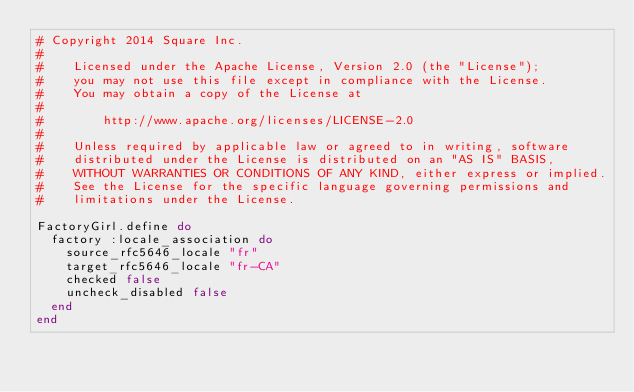<code> <loc_0><loc_0><loc_500><loc_500><_Ruby_># Copyright 2014 Square Inc.
#
#    Licensed under the Apache License, Version 2.0 (the "License");
#    you may not use this file except in compliance with the License.
#    You may obtain a copy of the License at
#
#        http://www.apache.org/licenses/LICENSE-2.0
#
#    Unless required by applicable law or agreed to in writing, software
#    distributed under the License is distributed on an "AS IS" BASIS,
#    WITHOUT WARRANTIES OR CONDITIONS OF ANY KIND, either express or implied.
#    See the License for the specific language governing permissions and
#    limitations under the License.

FactoryGirl.define do
  factory :locale_association do
    source_rfc5646_locale "fr"
    target_rfc5646_locale "fr-CA"
    checked false
    uncheck_disabled false
  end
end
</code> 